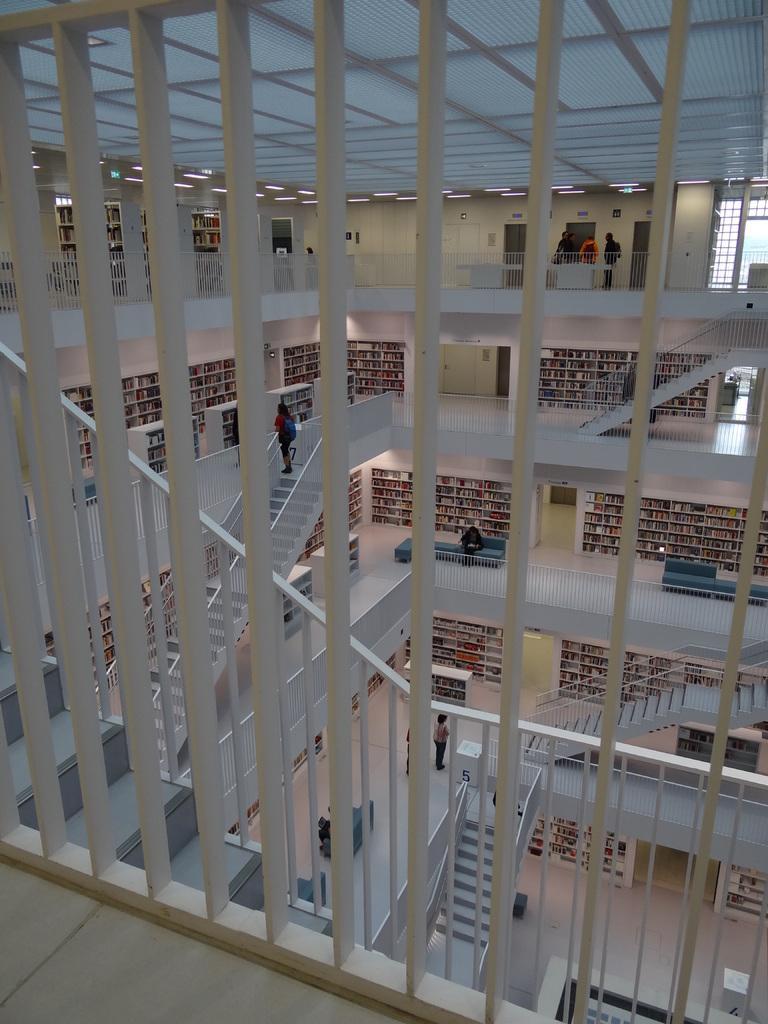Can you describe this image briefly? In this image, we can see an inside view of a building. There are grills and stairs in the middle of the image. 